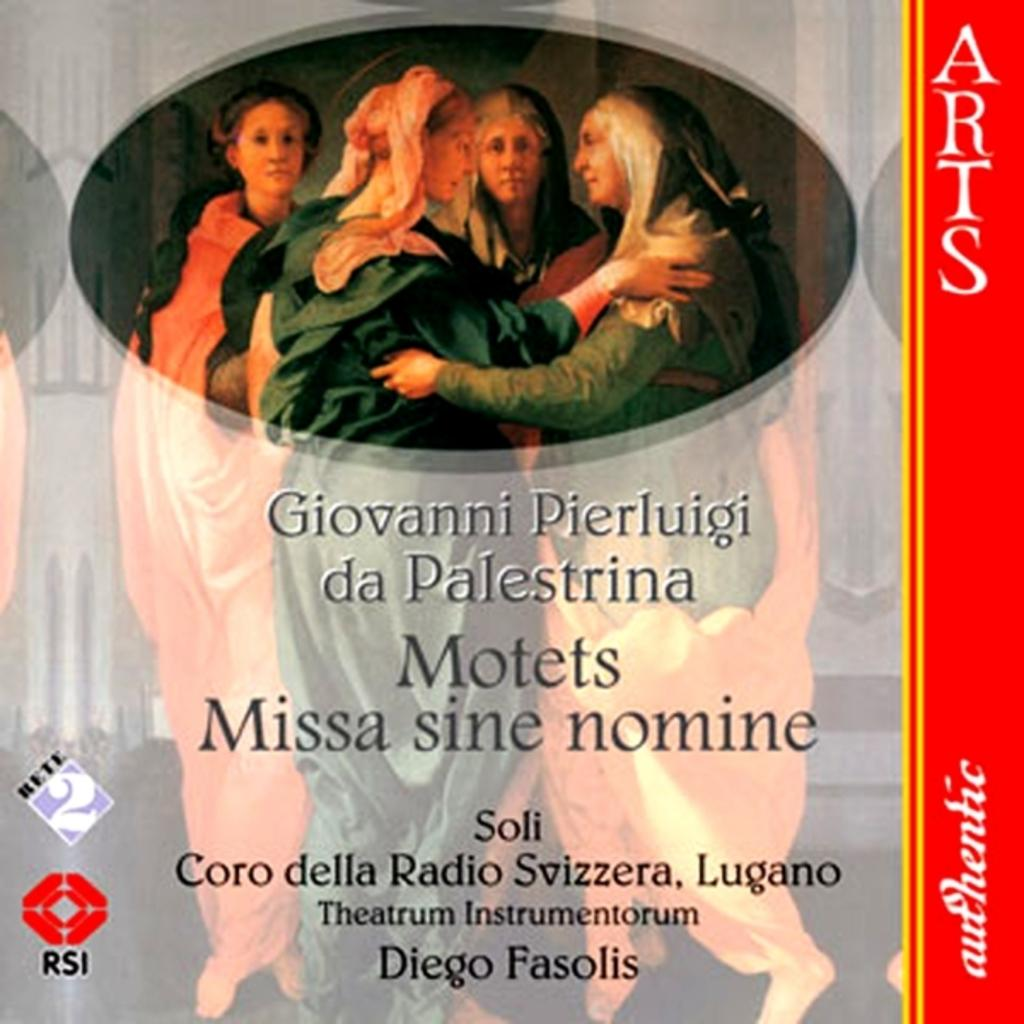<image>
Summarize the visual content of the image. Two painted women embrace in a poster for the arts. 